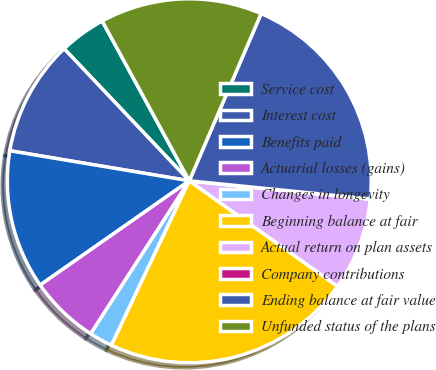Convert chart. <chart><loc_0><loc_0><loc_500><loc_500><pie_chart><fcel>Service cost<fcel>Interest cost<fcel>Benefits paid<fcel>Actuarial losses (gains)<fcel>Changes in longevity<fcel>Beginning balance at fair<fcel>Actual return on plan assets<fcel>Company contributions<fcel>Ending balance at fair value<fcel>Unfunded status of the plans<nl><fcel>4.13%<fcel>10.29%<fcel>12.35%<fcel>6.18%<fcel>2.07%<fcel>22.19%<fcel>8.24%<fcel>0.01%<fcel>20.14%<fcel>14.4%<nl></chart> 